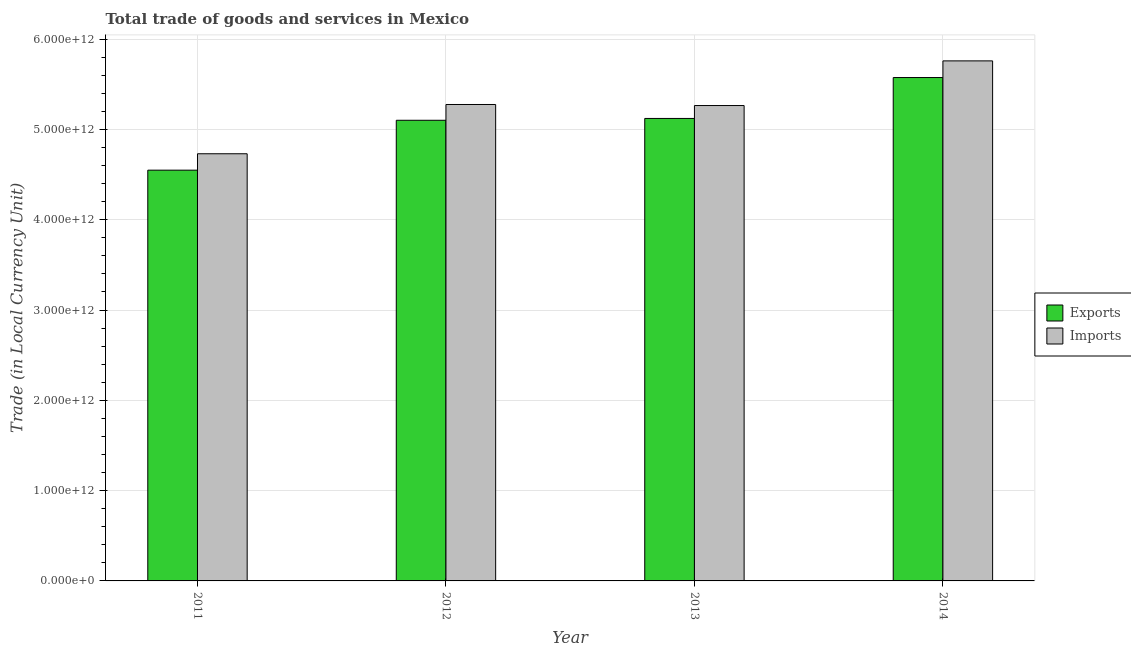How many groups of bars are there?
Make the answer very short. 4. Are the number of bars on each tick of the X-axis equal?
Provide a succinct answer. Yes. In how many cases, is the number of bars for a given year not equal to the number of legend labels?
Your answer should be compact. 0. What is the export of goods and services in 2013?
Your response must be concise. 5.12e+12. Across all years, what is the maximum imports of goods and services?
Ensure brevity in your answer.  5.76e+12. Across all years, what is the minimum imports of goods and services?
Keep it short and to the point. 4.73e+12. In which year was the imports of goods and services maximum?
Give a very brief answer. 2014. In which year was the export of goods and services minimum?
Ensure brevity in your answer.  2011. What is the total export of goods and services in the graph?
Make the answer very short. 2.03e+13. What is the difference between the imports of goods and services in 2012 and that in 2014?
Ensure brevity in your answer.  -4.83e+11. What is the difference between the export of goods and services in 2013 and the imports of goods and services in 2014?
Your response must be concise. -4.53e+11. What is the average imports of goods and services per year?
Your response must be concise. 5.26e+12. In how many years, is the imports of goods and services greater than 3000000000000 LCU?
Make the answer very short. 4. What is the ratio of the imports of goods and services in 2012 to that in 2014?
Give a very brief answer. 0.92. What is the difference between the highest and the second highest imports of goods and services?
Your answer should be very brief. 4.83e+11. What is the difference between the highest and the lowest export of goods and services?
Offer a terse response. 1.03e+12. What does the 2nd bar from the left in 2013 represents?
Provide a short and direct response. Imports. What does the 2nd bar from the right in 2011 represents?
Make the answer very short. Exports. How many years are there in the graph?
Provide a short and direct response. 4. What is the difference between two consecutive major ticks on the Y-axis?
Your answer should be very brief. 1.00e+12. Are the values on the major ticks of Y-axis written in scientific E-notation?
Provide a short and direct response. Yes. Does the graph contain grids?
Your response must be concise. Yes. Where does the legend appear in the graph?
Ensure brevity in your answer.  Center right. What is the title of the graph?
Your answer should be compact. Total trade of goods and services in Mexico. What is the label or title of the Y-axis?
Offer a very short reply. Trade (in Local Currency Unit). What is the Trade (in Local Currency Unit) of Exports in 2011?
Offer a terse response. 4.55e+12. What is the Trade (in Local Currency Unit) in Imports in 2011?
Keep it short and to the point. 4.73e+12. What is the Trade (in Local Currency Unit) in Exports in 2012?
Provide a short and direct response. 5.10e+12. What is the Trade (in Local Currency Unit) of Imports in 2012?
Provide a succinct answer. 5.28e+12. What is the Trade (in Local Currency Unit) in Exports in 2013?
Provide a succinct answer. 5.12e+12. What is the Trade (in Local Currency Unit) in Imports in 2013?
Your answer should be very brief. 5.26e+12. What is the Trade (in Local Currency Unit) of Exports in 2014?
Provide a succinct answer. 5.57e+12. What is the Trade (in Local Currency Unit) of Imports in 2014?
Your answer should be very brief. 5.76e+12. Across all years, what is the maximum Trade (in Local Currency Unit) of Exports?
Offer a very short reply. 5.57e+12. Across all years, what is the maximum Trade (in Local Currency Unit) in Imports?
Provide a succinct answer. 5.76e+12. Across all years, what is the minimum Trade (in Local Currency Unit) in Exports?
Provide a short and direct response. 4.55e+12. Across all years, what is the minimum Trade (in Local Currency Unit) in Imports?
Your answer should be very brief. 4.73e+12. What is the total Trade (in Local Currency Unit) of Exports in the graph?
Make the answer very short. 2.03e+13. What is the total Trade (in Local Currency Unit) of Imports in the graph?
Make the answer very short. 2.10e+13. What is the difference between the Trade (in Local Currency Unit) in Exports in 2011 and that in 2012?
Provide a succinct answer. -5.52e+11. What is the difference between the Trade (in Local Currency Unit) in Imports in 2011 and that in 2012?
Your answer should be very brief. -5.46e+11. What is the difference between the Trade (in Local Currency Unit) of Exports in 2011 and that in 2013?
Provide a short and direct response. -5.73e+11. What is the difference between the Trade (in Local Currency Unit) of Imports in 2011 and that in 2013?
Offer a terse response. -5.34e+11. What is the difference between the Trade (in Local Currency Unit) of Exports in 2011 and that in 2014?
Your response must be concise. -1.03e+12. What is the difference between the Trade (in Local Currency Unit) in Imports in 2011 and that in 2014?
Offer a terse response. -1.03e+12. What is the difference between the Trade (in Local Currency Unit) of Exports in 2012 and that in 2013?
Offer a very short reply. -2.02e+1. What is the difference between the Trade (in Local Currency Unit) of Imports in 2012 and that in 2013?
Offer a very short reply. 1.16e+1. What is the difference between the Trade (in Local Currency Unit) of Exports in 2012 and that in 2014?
Your answer should be compact. -4.73e+11. What is the difference between the Trade (in Local Currency Unit) in Imports in 2012 and that in 2014?
Keep it short and to the point. -4.83e+11. What is the difference between the Trade (in Local Currency Unit) in Exports in 2013 and that in 2014?
Your answer should be very brief. -4.53e+11. What is the difference between the Trade (in Local Currency Unit) of Imports in 2013 and that in 2014?
Give a very brief answer. -4.95e+11. What is the difference between the Trade (in Local Currency Unit) in Exports in 2011 and the Trade (in Local Currency Unit) in Imports in 2012?
Offer a very short reply. -7.27e+11. What is the difference between the Trade (in Local Currency Unit) of Exports in 2011 and the Trade (in Local Currency Unit) of Imports in 2013?
Your answer should be very brief. -7.16e+11. What is the difference between the Trade (in Local Currency Unit) of Exports in 2011 and the Trade (in Local Currency Unit) of Imports in 2014?
Keep it short and to the point. -1.21e+12. What is the difference between the Trade (in Local Currency Unit) in Exports in 2012 and the Trade (in Local Currency Unit) in Imports in 2013?
Ensure brevity in your answer.  -1.63e+11. What is the difference between the Trade (in Local Currency Unit) in Exports in 2012 and the Trade (in Local Currency Unit) in Imports in 2014?
Your answer should be compact. -6.58e+11. What is the difference between the Trade (in Local Currency Unit) in Exports in 2013 and the Trade (in Local Currency Unit) in Imports in 2014?
Offer a very short reply. -6.38e+11. What is the average Trade (in Local Currency Unit) of Exports per year?
Provide a short and direct response. 5.09e+12. What is the average Trade (in Local Currency Unit) in Imports per year?
Provide a short and direct response. 5.26e+12. In the year 2011, what is the difference between the Trade (in Local Currency Unit) in Exports and Trade (in Local Currency Unit) in Imports?
Your response must be concise. -1.82e+11. In the year 2012, what is the difference between the Trade (in Local Currency Unit) in Exports and Trade (in Local Currency Unit) in Imports?
Provide a short and direct response. -1.75e+11. In the year 2013, what is the difference between the Trade (in Local Currency Unit) of Exports and Trade (in Local Currency Unit) of Imports?
Keep it short and to the point. -1.43e+11. In the year 2014, what is the difference between the Trade (in Local Currency Unit) of Exports and Trade (in Local Currency Unit) of Imports?
Provide a short and direct response. -1.85e+11. What is the ratio of the Trade (in Local Currency Unit) of Exports in 2011 to that in 2012?
Offer a terse response. 0.89. What is the ratio of the Trade (in Local Currency Unit) of Imports in 2011 to that in 2012?
Make the answer very short. 0.9. What is the ratio of the Trade (in Local Currency Unit) in Exports in 2011 to that in 2013?
Give a very brief answer. 0.89. What is the ratio of the Trade (in Local Currency Unit) in Imports in 2011 to that in 2013?
Provide a succinct answer. 0.9. What is the ratio of the Trade (in Local Currency Unit) of Exports in 2011 to that in 2014?
Your response must be concise. 0.82. What is the ratio of the Trade (in Local Currency Unit) of Imports in 2011 to that in 2014?
Provide a succinct answer. 0.82. What is the ratio of the Trade (in Local Currency Unit) of Imports in 2012 to that in 2013?
Provide a succinct answer. 1. What is the ratio of the Trade (in Local Currency Unit) in Exports in 2012 to that in 2014?
Provide a succinct answer. 0.92. What is the ratio of the Trade (in Local Currency Unit) in Imports in 2012 to that in 2014?
Give a very brief answer. 0.92. What is the ratio of the Trade (in Local Currency Unit) in Exports in 2013 to that in 2014?
Offer a very short reply. 0.92. What is the ratio of the Trade (in Local Currency Unit) in Imports in 2013 to that in 2014?
Provide a short and direct response. 0.91. What is the difference between the highest and the second highest Trade (in Local Currency Unit) of Exports?
Your answer should be very brief. 4.53e+11. What is the difference between the highest and the second highest Trade (in Local Currency Unit) of Imports?
Ensure brevity in your answer.  4.83e+11. What is the difference between the highest and the lowest Trade (in Local Currency Unit) of Exports?
Make the answer very short. 1.03e+12. What is the difference between the highest and the lowest Trade (in Local Currency Unit) of Imports?
Keep it short and to the point. 1.03e+12. 